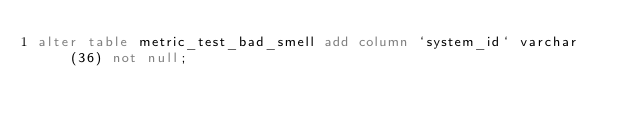Convert code to text. <code><loc_0><loc_0><loc_500><loc_500><_SQL_>alter table metric_test_bad_smell add column `system_id` varchar(36) not null;</code> 